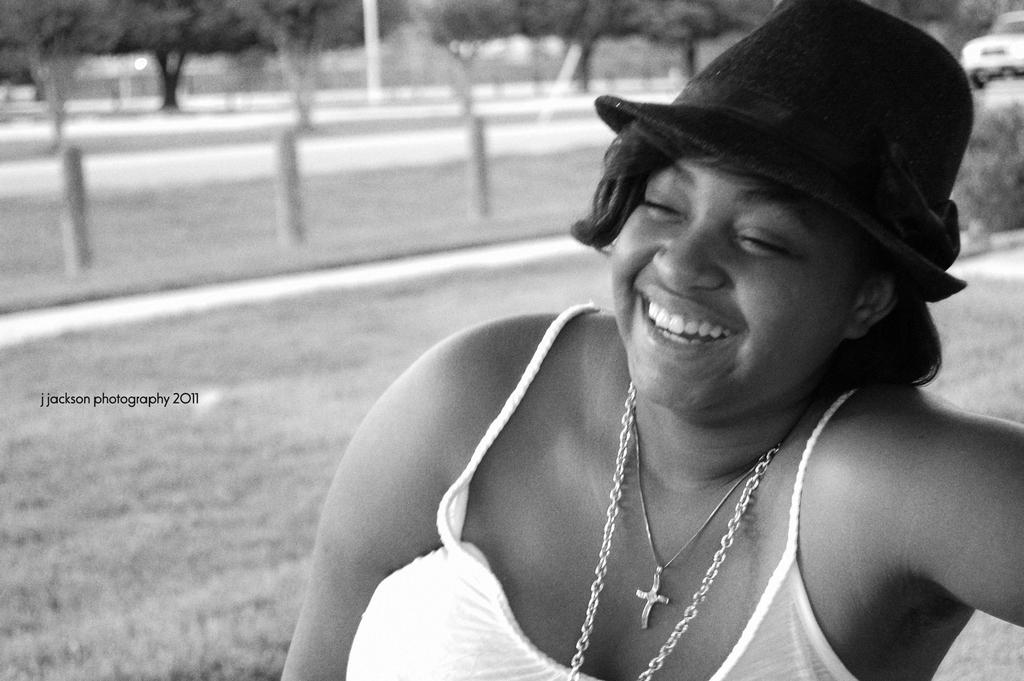Who or what is present in the image? There is a person in the image. What is the person wearing on their head? The person is wearing a cap. What can be seen in the distance behind the person? There are trees and poles in the background of the image. How is the image presented in terms of color? The image is in black and white. What type of thread is being used to create a shocking effect in the image? There is no thread or shocking effect present in the image. What is the person holding on the tray in the image? There is no tray or any object being held by the person in the image. 